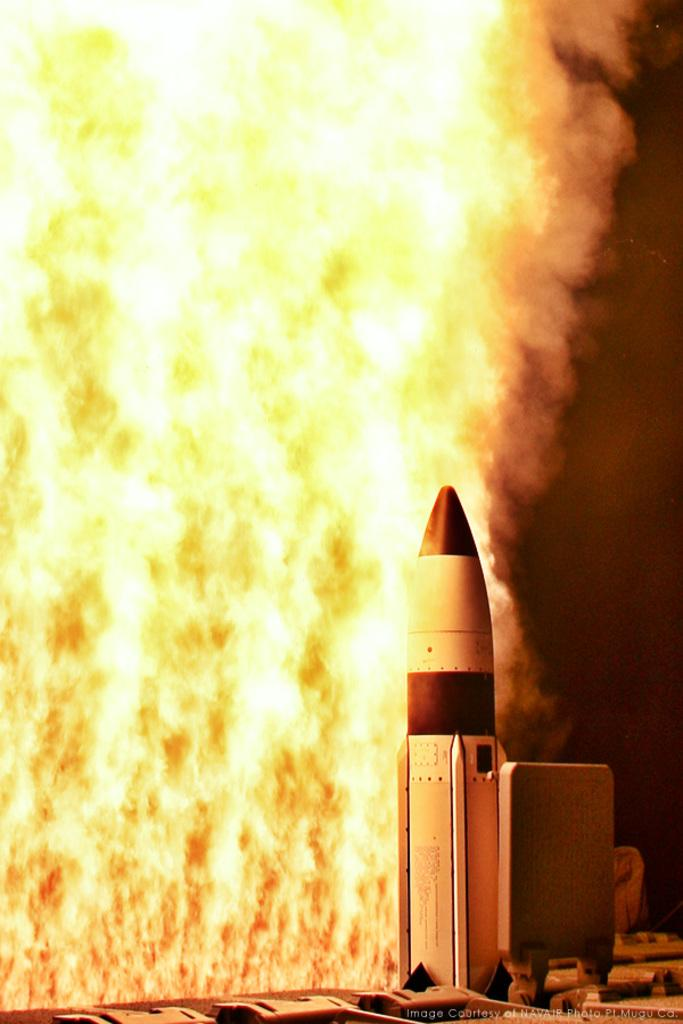What is the main subject of the image? The main subject of the image is a missile. What can be observed about the missile in the image? There is fire visible on the backside of the missile. What else is visible in the image? There is smoke visible in the image. What type of body is visible in the image? There is no body present in the image; it features a missile with fire and smoke. What committee is responsible for the play depicted in the image? There is no committee or play depicted in the image; it features a missile with fire and smoke. 